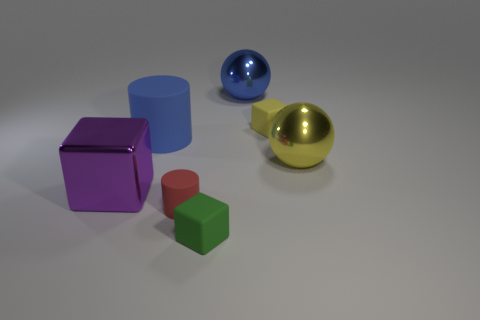Add 2 yellow rubber blocks. How many objects exist? 9 Subtract all balls. How many objects are left? 5 Subtract 1 yellow balls. How many objects are left? 6 Subtract all small green matte objects. Subtract all large blue rubber spheres. How many objects are left? 6 Add 3 yellow metallic spheres. How many yellow metallic spheres are left? 4 Add 6 yellow blocks. How many yellow blocks exist? 7 